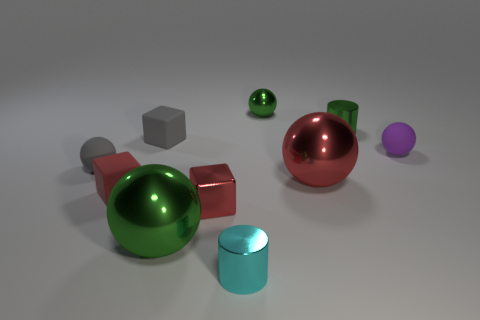What is the shape of the shiny object that is the same color as the tiny shiny cube?
Your answer should be very brief. Sphere. Are there any large purple blocks made of the same material as the big green object?
Offer a very short reply. No. Do the small gray cube and the cylinder that is in front of the purple thing have the same material?
Give a very brief answer. No. The metal ball that is the same size as the shiny block is what color?
Provide a short and direct response. Green. There is a green ball in front of the tiny purple object in front of the tiny gray rubber block; what is its size?
Your answer should be very brief. Large. There is a shiny cube; is its color the same as the big metal ball to the right of the metal cube?
Keep it short and to the point. Yes. Is the number of tiny gray things that are in front of the red metallic block less than the number of big blue spheres?
Give a very brief answer. No. How many other things are there of the same size as the cyan cylinder?
Ensure brevity in your answer.  7. Do the big metallic object to the right of the big green metal sphere and the purple matte thing have the same shape?
Offer a very short reply. Yes. Is the number of green shiny objects that are on the left side of the tiny purple rubber sphere greater than the number of brown rubber objects?
Provide a short and direct response. Yes. 